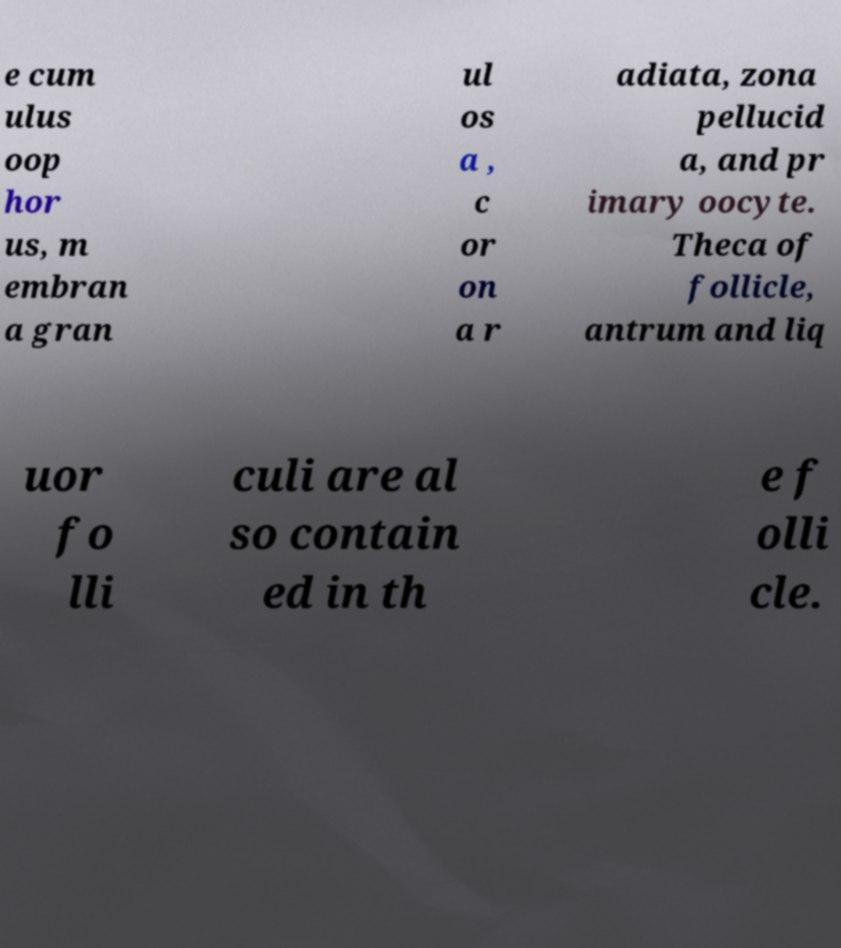There's text embedded in this image that I need extracted. Can you transcribe it verbatim? e cum ulus oop hor us, m embran a gran ul os a , c or on a r adiata, zona pellucid a, and pr imary oocyte. Theca of follicle, antrum and liq uor fo lli culi are al so contain ed in th e f olli cle. 